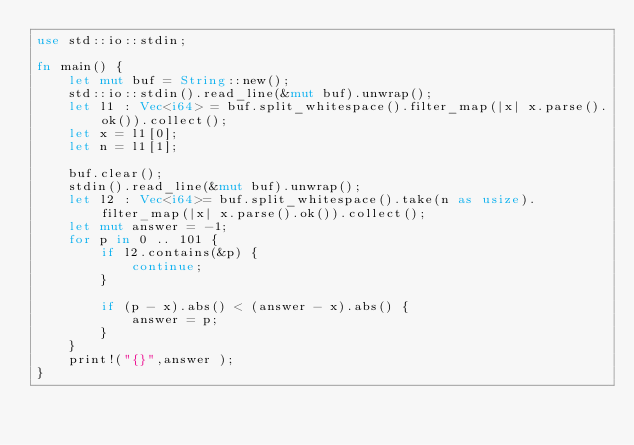Convert code to text. <code><loc_0><loc_0><loc_500><loc_500><_Rust_>use std::io::stdin;

fn main() {
    let mut buf = String::new();
    std::io::stdin().read_line(&mut buf).unwrap();
    let l1 : Vec<i64> = buf.split_whitespace().filter_map(|x| x.parse().ok()).collect();
    let x = l1[0];
    let n = l1[1];

    buf.clear();
    stdin().read_line(&mut buf).unwrap();
    let l2 : Vec<i64>= buf.split_whitespace().take(n as usize).filter_map(|x| x.parse().ok()).collect();
    let mut answer = -1;
    for p in 0 .. 101 {
        if l2.contains(&p) {
            continue;
        }

        if (p - x).abs() < (answer - x).abs() {
            answer = p;
        }
    }
    print!("{}",answer );
}
</code> 